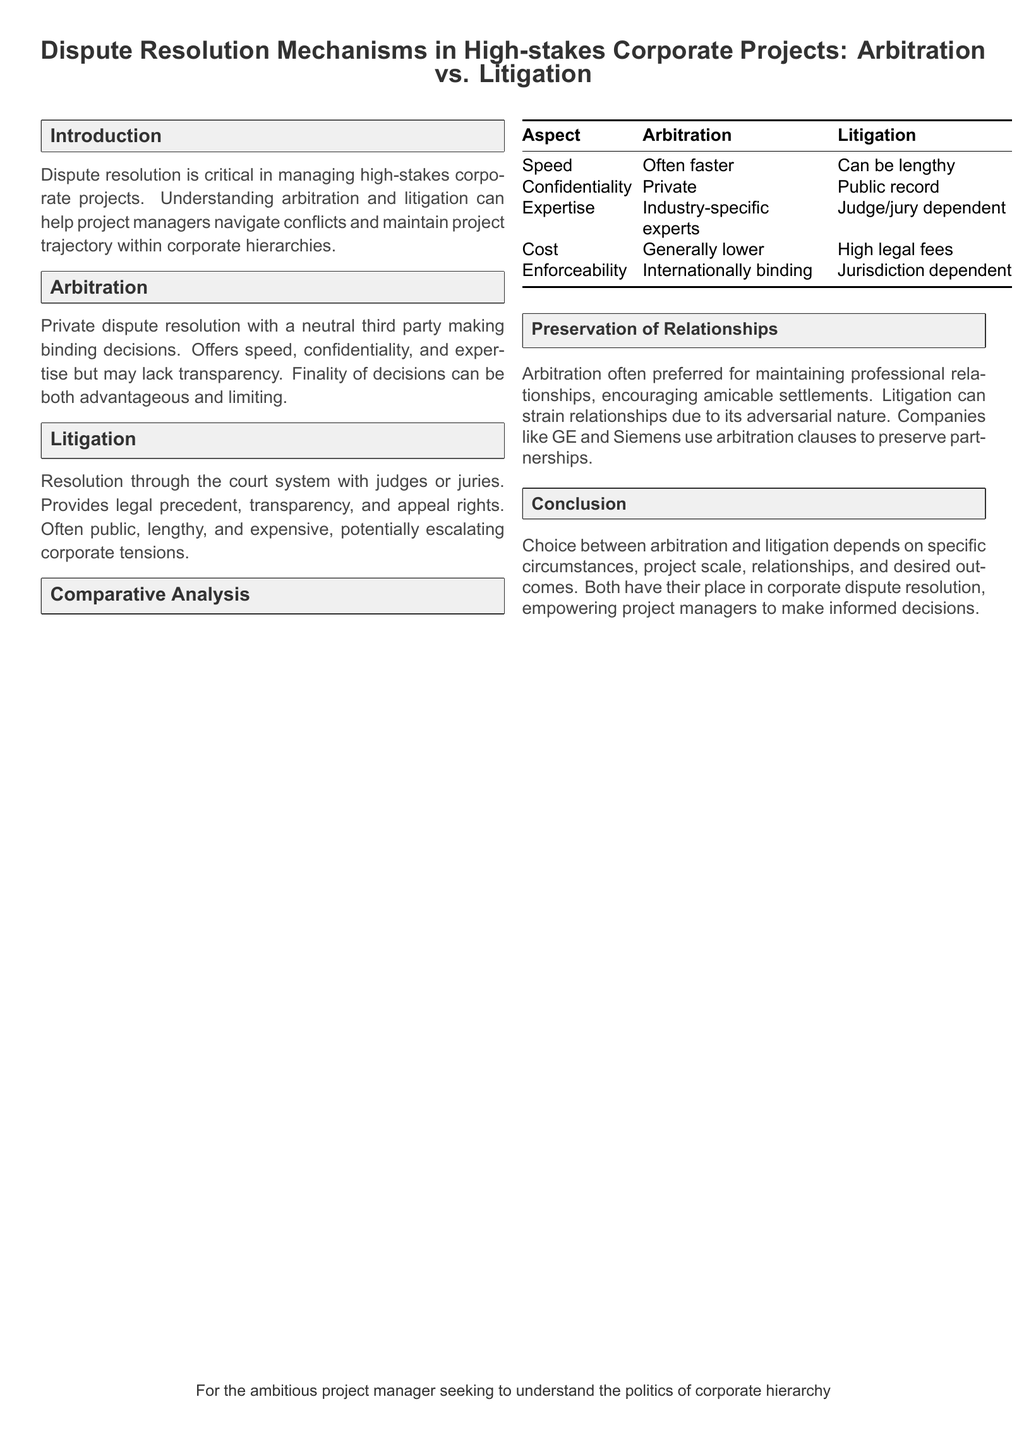What is the primary focus of the document? The document focuses on the dispute resolution mechanisms in high-stakes corporate projects.
Answer: Dispute resolution mechanisms in high-stakes corporate projects What are the two main dispute resolution methods discussed? The document specifically mentions arbitration and litigation as the two methods.
Answer: Arbitration and litigation Which method is generally faster? The document indicates that arbitration is typically quicker than litigation.
Answer: Faster What aspect of litigation can strain corporate relationships? The adversarial nature of litigation is likely to strain corporate relationships according to the document.
Answer: Adversarial nature Which companies are mentioned as using arbitration clauses? The document references GE and Siemens as companies that utilize arbitration clauses.
Answer: GE and Siemens What advantage does arbitration offer regarding confidentiality? The document states that arbitration proceedings are private, offering confidentiality.
Answer: Private What is a disadvantage of arbitration mentioned in the document? The document notes that arbitration may lack transparency as a disadvantage.
Answer: Lack of transparency Which dispute resolution method provides appeal rights? The document specifies that litigation offers the right to appeal.
Answer: Litigation What is one characteristic of arbitration in terms of decision-making? The document describes arbitration as involving a neutral third party making binding decisions.
Answer: Binding decisions What does the comparative analysis table provide? The table compares various aspects of arbitration and litigation across multiple criteria.
Answer: Comparison of aspects 